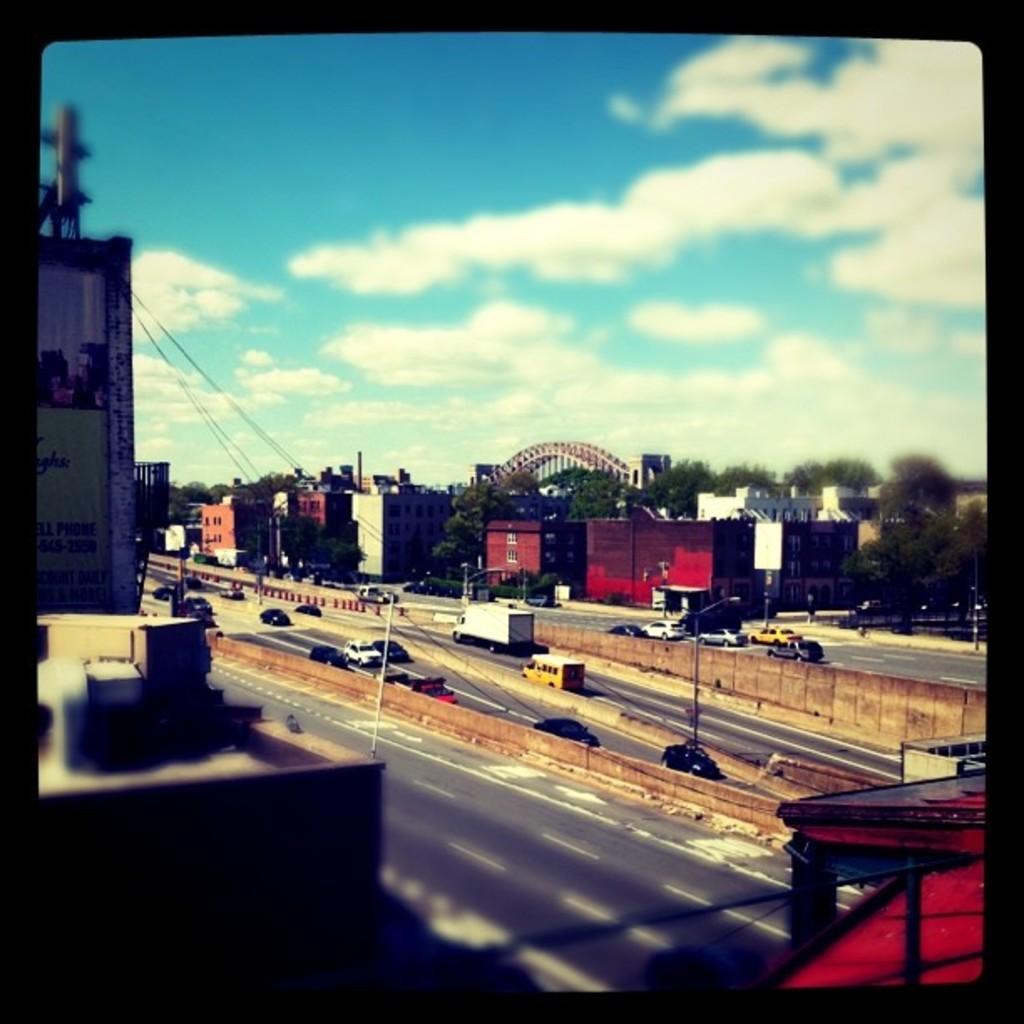Could you give a brief overview of what you see in this image? In this picture there is a top view of the road. In the front some cars are moving on the road. In the background there is a red color building and metal frame bridge with some trees. Above there is blue sky with clouds. 